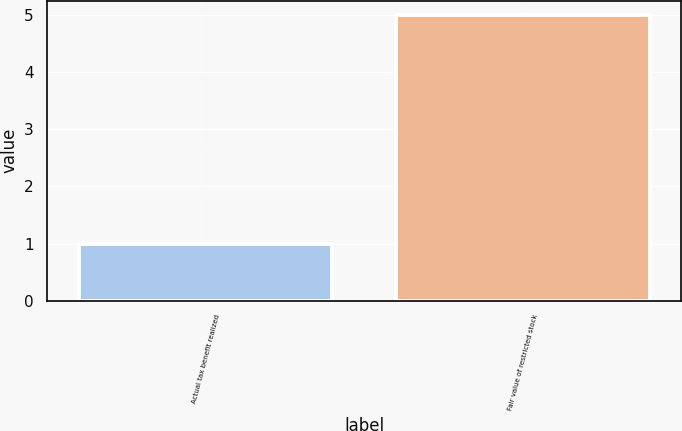Convert chart. <chart><loc_0><loc_0><loc_500><loc_500><bar_chart><fcel>Actual tax benefit realized<fcel>Fair value of restricted stock<nl><fcel>1<fcel>5<nl></chart> 